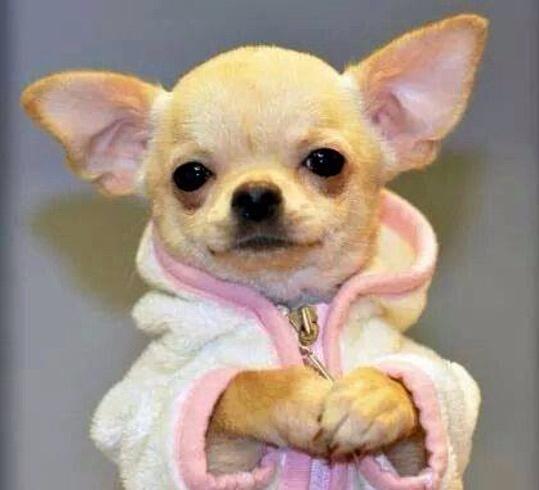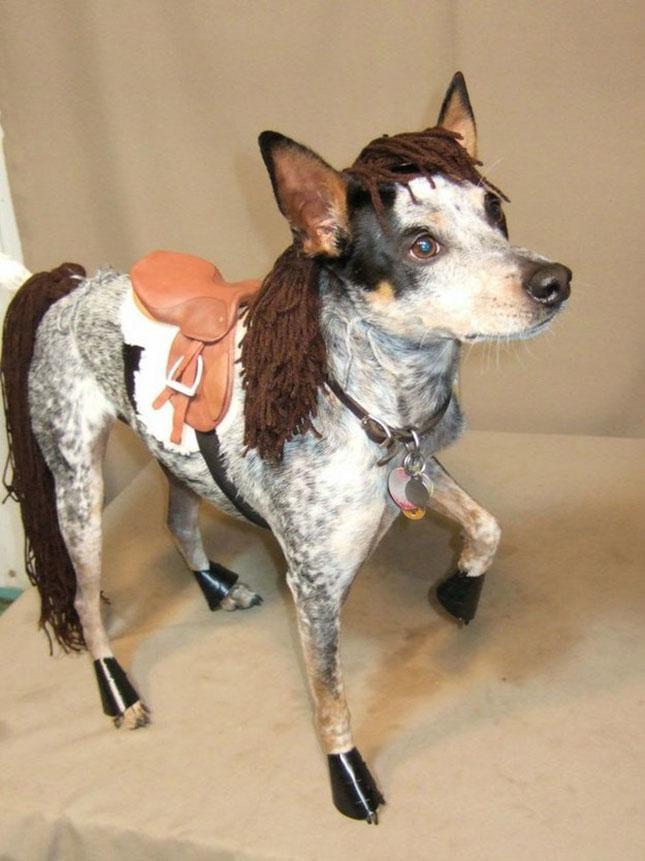The first image is the image on the left, the second image is the image on the right. Assess this claim about the two images: "At least one of the dogs is wearing a hat on it's head.". Correct or not? Answer yes or no. No. The first image is the image on the left, the second image is the image on the right. Assess this claim about the two images: "A dog wears a hat in at least one image.". Correct or not? Answer yes or no. No. 